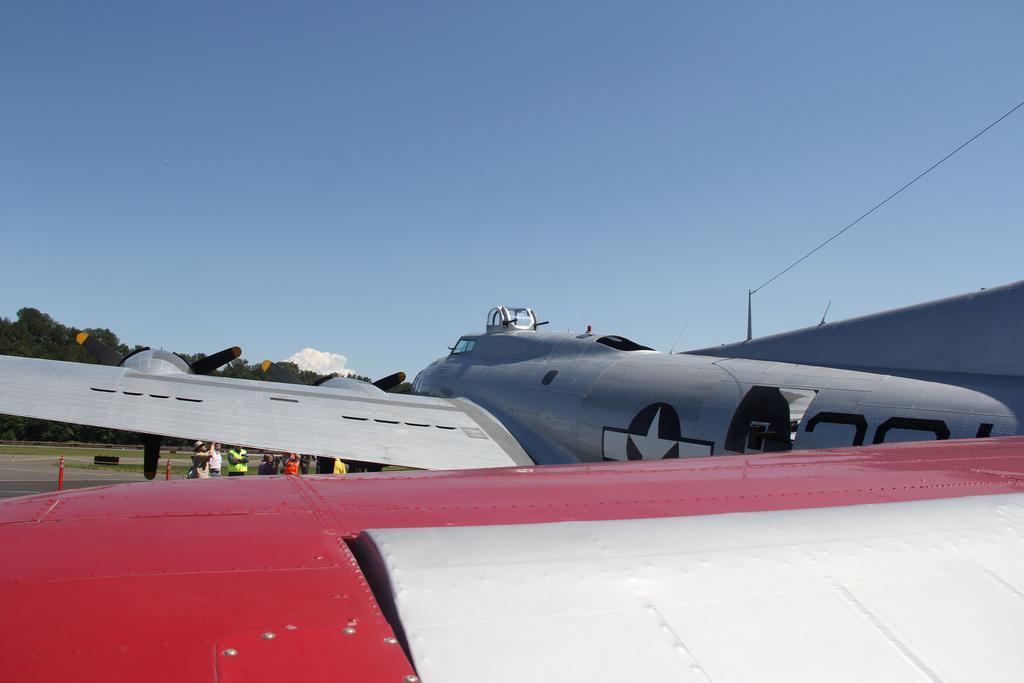Describe this image in one or two sentences. There is an aircraft and a cable in the foreground area of the image, there are people, trees and the sky in the background. 